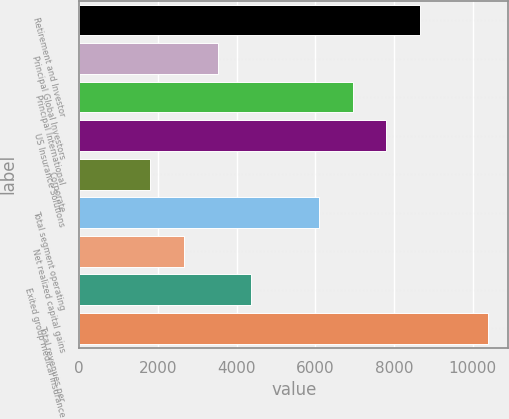Convert chart. <chart><loc_0><loc_0><loc_500><loc_500><bar_chart><fcel>Retirement and Investor<fcel>Principal Global Investors<fcel>Principal International<fcel>US Insurance Solutions<fcel>Corporate<fcel>Total segment operating<fcel>Net realized capital gains<fcel>Exited group medical insurance<fcel>Total revenues per<nl><fcel>8670.7<fcel>3517.66<fcel>6953.02<fcel>7811.86<fcel>1799.98<fcel>6094.18<fcel>2658.82<fcel>4376.5<fcel>10388.4<nl></chart> 